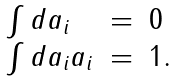<formula> <loc_0><loc_0><loc_500><loc_500>\begin{array} { l c l } \int d a _ { i } & = & 0 \\ \int d a _ { i } a _ { i } & = & 1 . \end{array}</formula> 